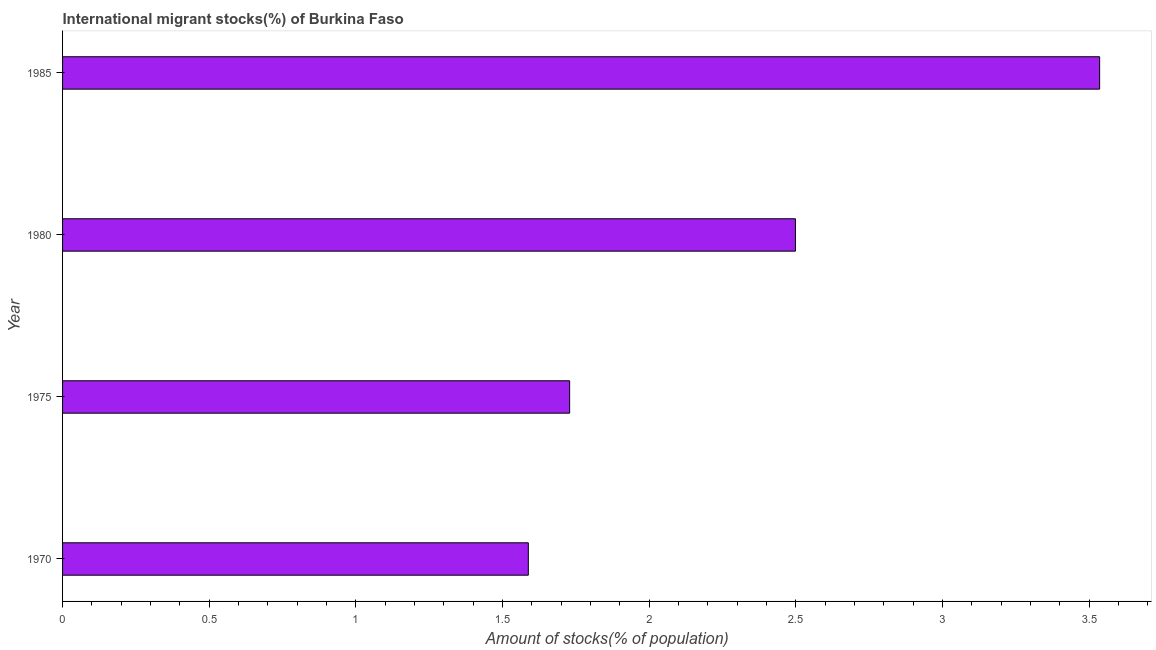Does the graph contain any zero values?
Offer a very short reply. No. What is the title of the graph?
Ensure brevity in your answer.  International migrant stocks(%) of Burkina Faso. What is the label or title of the X-axis?
Provide a succinct answer. Amount of stocks(% of population). What is the number of international migrant stocks in 1970?
Offer a terse response. 1.59. Across all years, what is the maximum number of international migrant stocks?
Make the answer very short. 3.54. Across all years, what is the minimum number of international migrant stocks?
Provide a short and direct response. 1.59. In which year was the number of international migrant stocks minimum?
Make the answer very short. 1970. What is the sum of the number of international migrant stocks?
Your answer should be very brief. 9.35. What is the difference between the number of international migrant stocks in 1970 and 1975?
Your answer should be compact. -0.14. What is the average number of international migrant stocks per year?
Give a very brief answer. 2.34. What is the median number of international migrant stocks?
Keep it short and to the point. 2.11. In how many years, is the number of international migrant stocks greater than 3.3 %?
Your answer should be compact. 1. What is the ratio of the number of international migrant stocks in 1975 to that in 1985?
Offer a very short reply. 0.49. What is the difference between the highest and the second highest number of international migrant stocks?
Provide a succinct answer. 1.04. Is the sum of the number of international migrant stocks in 1980 and 1985 greater than the maximum number of international migrant stocks across all years?
Your answer should be very brief. Yes. What is the difference between the highest and the lowest number of international migrant stocks?
Your response must be concise. 1.95. Are all the bars in the graph horizontal?
Ensure brevity in your answer.  Yes. How many years are there in the graph?
Offer a very short reply. 4. What is the difference between two consecutive major ticks on the X-axis?
Keep it short and to the point. 0.5. Are the values on the major ticks of X-axis written in scientific E-notation?
Give a very brief answer. No. What is the Amount of stocks(% of population) of 1970?
Your answer should be compact. 1.59. What is the Amount of stocks(% of population) in 1975?
Provide a short and direct response. 1.73. What is the Amount of stocks(% of population) of 1980?
Keep it short and to the point. 2.5. What is the Amount of stocks(% of population) of 1985?
Your response must be concise. 3.54. What is the difference between the Amount of stocks(% of population) in 1970 and 1975?
Give a very brief answer. -0.14. What is the difference between the Amount of stocks(% of population) in 1970 and 1980?
Keep it short and to the point. -0.91. What is the difference between the Amount of stocks(% of population) in 1970 and 1985?
Offer a terse response. -1.95. What is the difference between the Amount of stocks(% of population) in 1975 and 1980?
Provide a short and direct response. -0.77. What is the difference between the Amount of stocks(% of population) in 1975 and 1985?
Your response must be concise. -1.81. What is the difference between the Amount of stocks(% of population) in 1980 and 1985?
Your response must be concise. -1.04. What is the ratio of the Amount of stocks(% of population) in 1970 to that in 1975?
Give a very brief answer. 0.92. What is the ratio of the Amount of stocks(% of population) in 1970 to that in 1980?
Give a very brief answer. 0.64. What is the ratio of the Amount of stocks(% of population) in 1970 to that in 1985?
Give a very brief answer. 0.45. What is the ratio of the Amount of stocks(% of population) in 1975 to that in 1980?
Provide a succinct answer. 0.69. What is the ratio of the Amount of stocks(% of population) in 1975 to that in 1985?
Make the answer very short. 0.49. What is the ratio of the Amount of stocks(% of population) in 1980 to that in 1985?
Your answer should be compact. 0.71. 